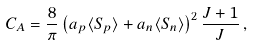Convert formula to latex. <formula><loc_0><loc_0><loc_500><loc_500>C _ { A } = \frac { 8 } { \pi } \left ( a _ { p } \langle S _ { p } \rangle + a _ { n } \langle S _ { n } \rangle \right ) ^ { 2 } \frac { J + 1 } { J } \, ,</formula> 